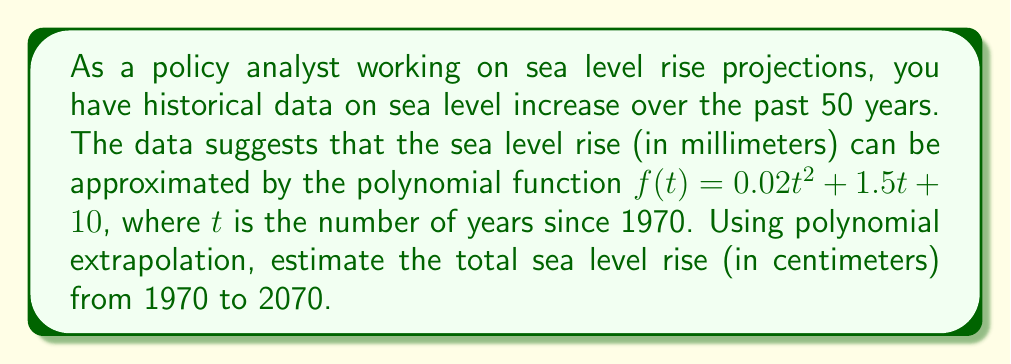Help me with this question. To solve this problem, we need to follow these steps:

1) The polynomial function given is:
   $f(t) = 0.02t^2 + 1.5t + 10$

2) We need to find the difference between $f(100)$ and $f(0)$, as 2070 is 100 years after 1970.

3) Calculate $f(100)$:
   $f(100) = 0.02(100)^2 + 1.5(100) + 10$
   $= 0.02(10000) + 150 + 10$
   $= 200 + 150 + 10$
   $= 360$ mm

4) Calculate $f(0)$:
   $f(0) = 0.02(0)^2 + 1.5(0) + 10$
   $= 0 + 0 + 10$
   $= 10$ mm

5) Calculate the difference:
   $360$ mm $- 10$ mm $= 350$ mm

6) Convert mm to cm:
   $350$ mm $= 35$ cm

Therefore, the total sea level rise from 1970 to 2070 is estimated to be 35 cm.
Answer: 35 cm 